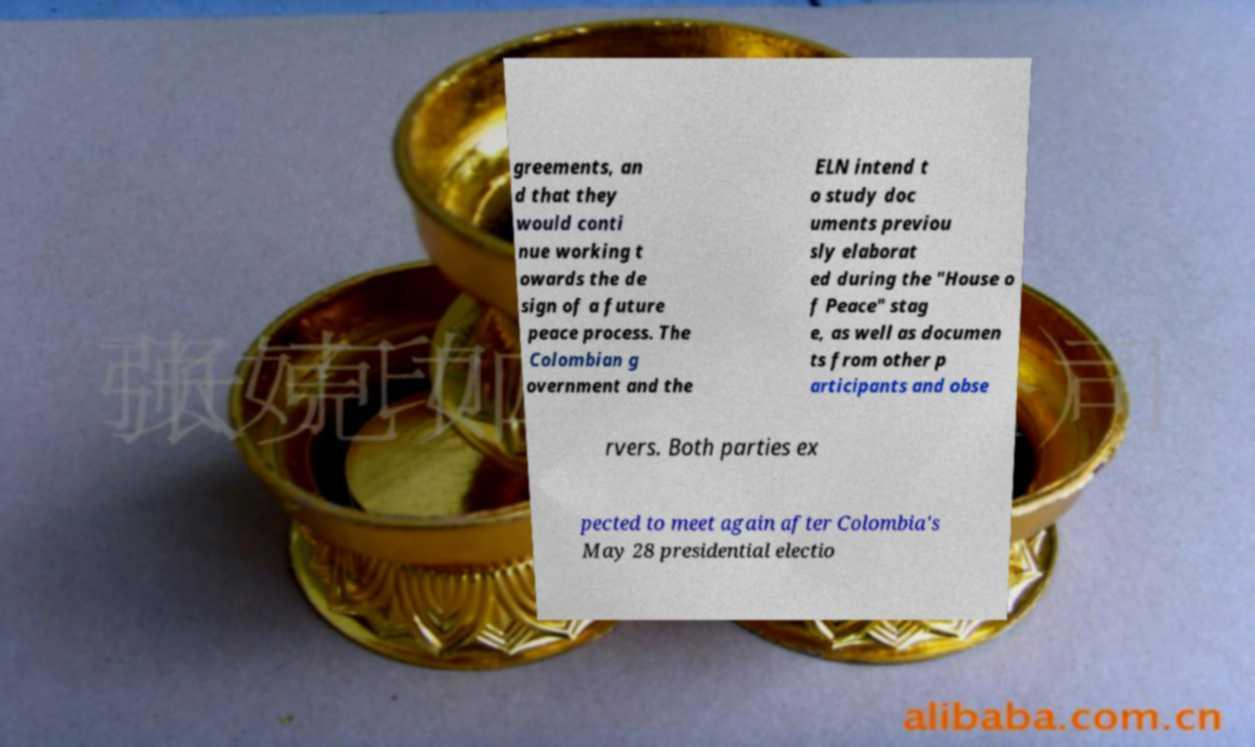What messages or text are displayed in this image? I need them in a readable, typed format. greements, an d that they would conti nue working t owards the de sign of a future peace process. The Colombian g overnment and the ELN intend t o study doc uments previou sly elaborat ed during the "House o f Peace" stag e, as well as documen ts from other p articipants and obse rvers. Both parties ex pected to meet again after Colombia's May 28 presidential electio 